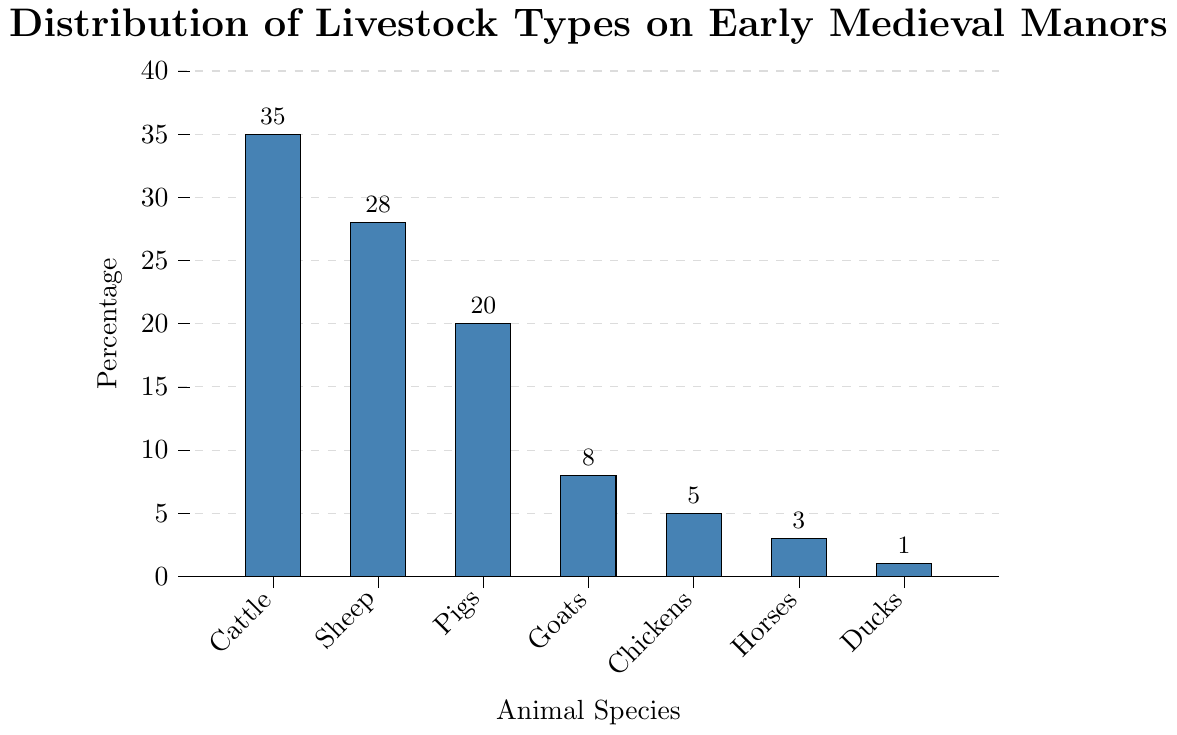What's the most common livestock type on Early Medieval manors? The tallest bar in the chart represents the most common livestock type, which is "Cattle" at 35%.
Answer: Cattle Which animal species has the least representation in Early Medieval manors? The shortest bar in the chart represents the least common livestock type, which is "Ducks" at 1%.
Answer: Ducks How much more common are sheep compared to ducks? The percentage of sheep is 28% while that of ducks is 1%. Subtracting the percentage of ducks from the percentage of sheep gives 28 - 1 = 27%.
Answer: 27% What is the total percentage of livestock accounted for by pigs, goats, and chickens combined? Summing the percentages of pigs, goats, and chickens gives 20% + 8% + 5% = 33%.
Answer: 33% How much less common are horses compared to cattle? The percentage of horses is 3% and the percentage of cattle is 35%. Subtracting the percentage of horses from cattle gives 35 - 3 = 32%.
Answer: 32% Are goats more or less common than chickens? The bar representing goats is taller than the bar representing chickens. Goats are at 8% while chickens are at 5%. Thus, goats are more common.
Answer: More common What is the average percentage of sheep, pigs, and goats? The percentage for sheep is 28%, pigs are 20%, and goats are 8%. Adding these values gives 28 + 20 + 8 = 56. Dividing by 3 (the number of species) gives 56 / 3 ≈ 18.67%.
Answer: 18.67% By how much do the combined percentages of cattle and sheep exceed the combined percentages of horses and ducks? Summing the percentages of cattle and sheep gives 35% + 28% = 63%. Summing the percentages of horses and ducks gives 3% + 1% = 4%. Subtracting the combined percentage of horses and ducks from the combined percentage of cattle and sheep gives 63 - 4 = 59%.
Answer: 59% What is the total percentage of all livestock types shown in the chart? Summing the percentages of all livestock types gives 35% (Cattle) + 28% (Sheep) + 20% (Pigs) + 8% (Goats) + 5% (Chickens) + 3% (Horses) + 1% (Ducks) = 100%.
Answer: 100% 